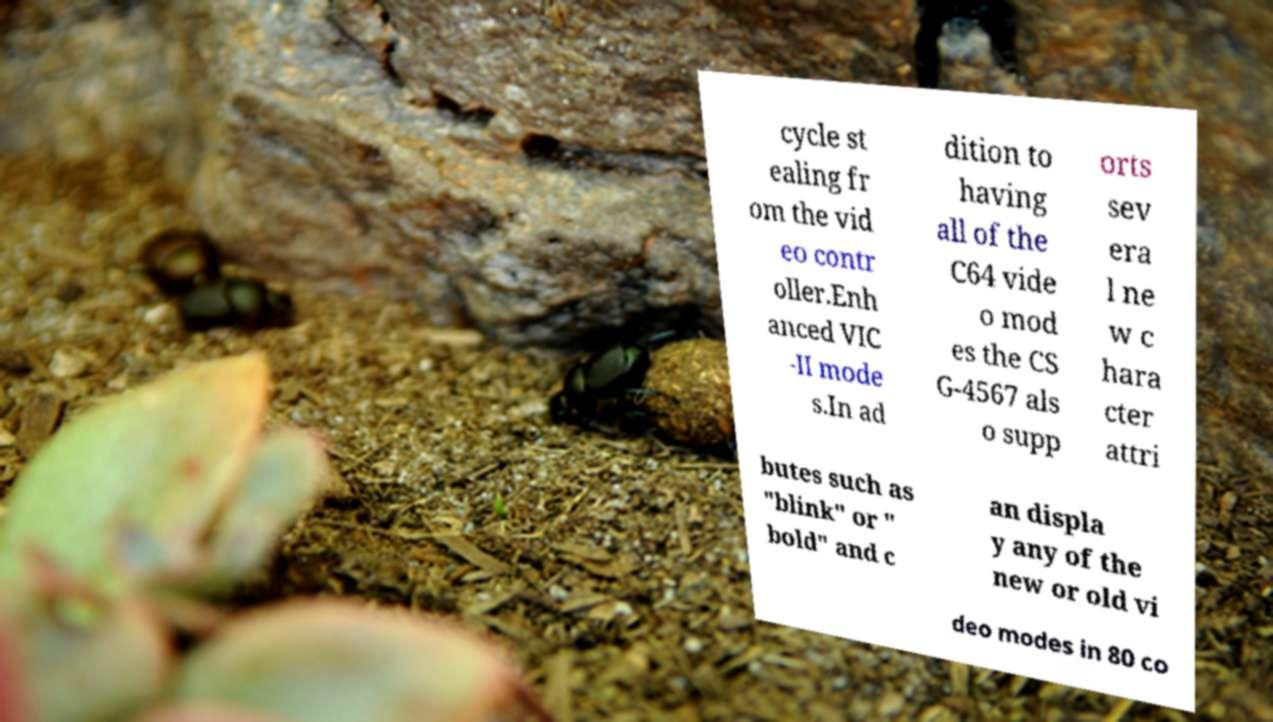I need the written content from this picture converted into text. Can you do that? cycle st ealing fr om the vid eo contr oller.Enh anced VIC -II mode s.In ad dition to having all of the C64 vide o mod es the CS G-4567 als o supp orts sev era l ne w c hara cter attri butes such as "blink" or " bold" and c an displa y any of the new or old vi deo modes in 80 co 